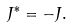<formula> <loc_0><loc_0><loc_500><loc_500>J ^ { * } = - J .</formula> 